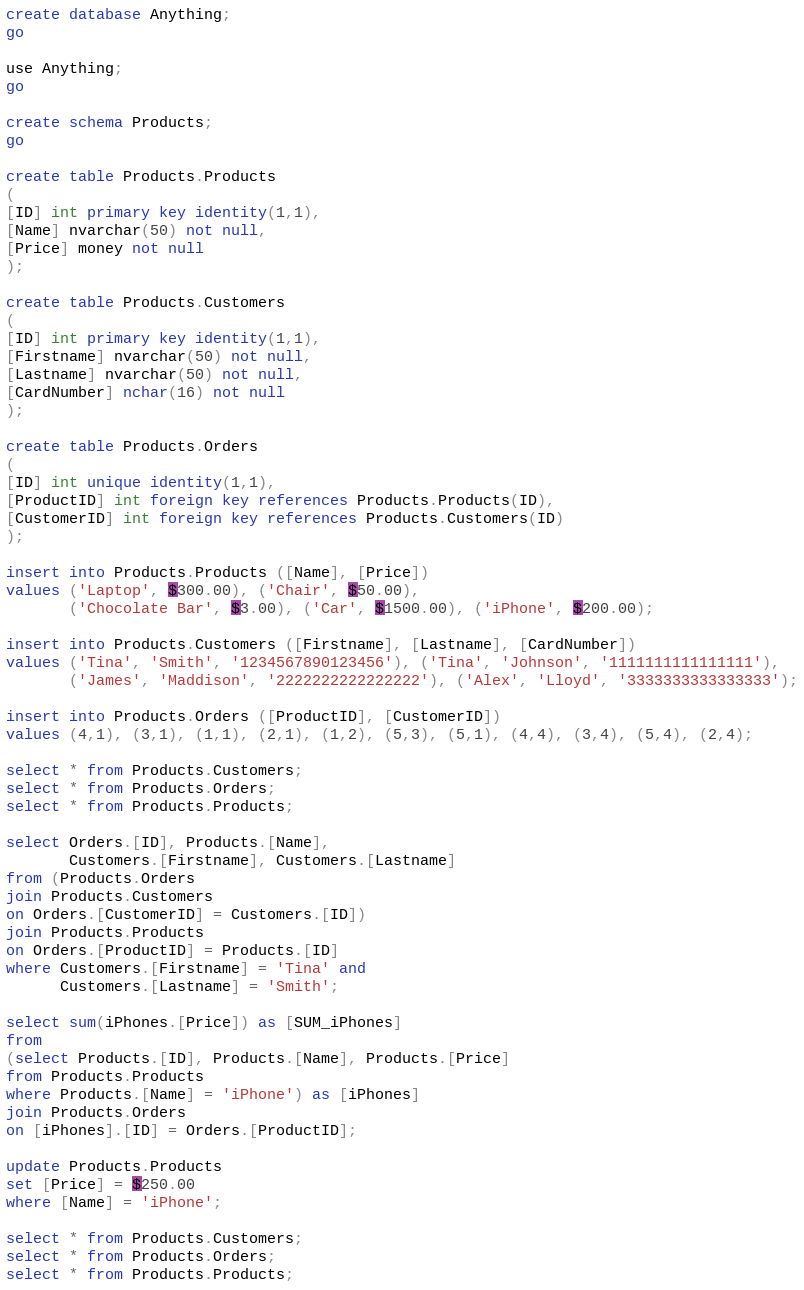<code> <loc_0><loc_0><loc_500><loc_500><_SQL_>create database Anything;
go

use Anything;
go

create schema Products;
go

create table Products.Products
(
[ID] int primary key identity(1,1),
[Name] nvarchar(50) not null,
[Price] money not null
);

create table Products.Customers
(
[ID] int primary key identity(1,1),
[Firstname] nvarchar(50) not null,
[Lastname] nvarchar(50) not null,
[CardNumber] nchar(16) not null
);

create table Products.Orders
(
[ID] int unique identity(1,1),
[ProductID] int foreign key references Products.Products(ID),
[CustomerID] int foreign key references Products.Customers(ID)
);

insert into Products.Products ([Name], [Price])
values ('Laptop', $300.00), ('Chair', $50.00), 
       ('Chocolate Bar', $3.00), ('Car', $1500.00), ('iPhone', $200.00);

insert into Products.Customers ([Firstname], [Lastname], [CardNumber])
values ('Tina', 'Smith', '1234567890123456'), ('Tina', 'Johnson', '1111111111111111'),
       ('James', 'Maddison', '2222222222222222'), ('Alex', 'Lloyd', '3333333333333333');

insert into Products.Orders ([ProductID], [CustomerID])
values (4,1), (3,1), (1,1), (2,1), (1,2), (5,3), (5,1), (4,4), (3,4), (5,4), (2,4);

select * from Products.Customers;
select * from Products.Orders;
select * from Products.Products;

select Orders.[ID], Products.[Name], 
       Customers.[Firstname], Customers.[Lastname]
from (Products.Orders
join Products.Customers
on Orders.[CustomerID] = Customers.[ID])
join Products.Products
on Orders.[ProductID] = Products.[ID]
where Customers.[Firstname] = 'Tina' and 
      Customers.[Lastname] = 'Smith';

select sum(iPhones.[Price]) as [SUM_iPhones]
from 
(select Products.[ID], Products.[Name], Products.[Price]
from Products.Products
where Products.[Name] = 'iPhone') as [iPhones]
join Products.Orders
on [iPhones].[ID] = Orders.[ProductID];

update Products.Products
set [Price] = $250.00
where [Name] = 'iPhone';

select * from Products.Customers;
select * from Products.Orders;
select * from Products.Products;
</code> 